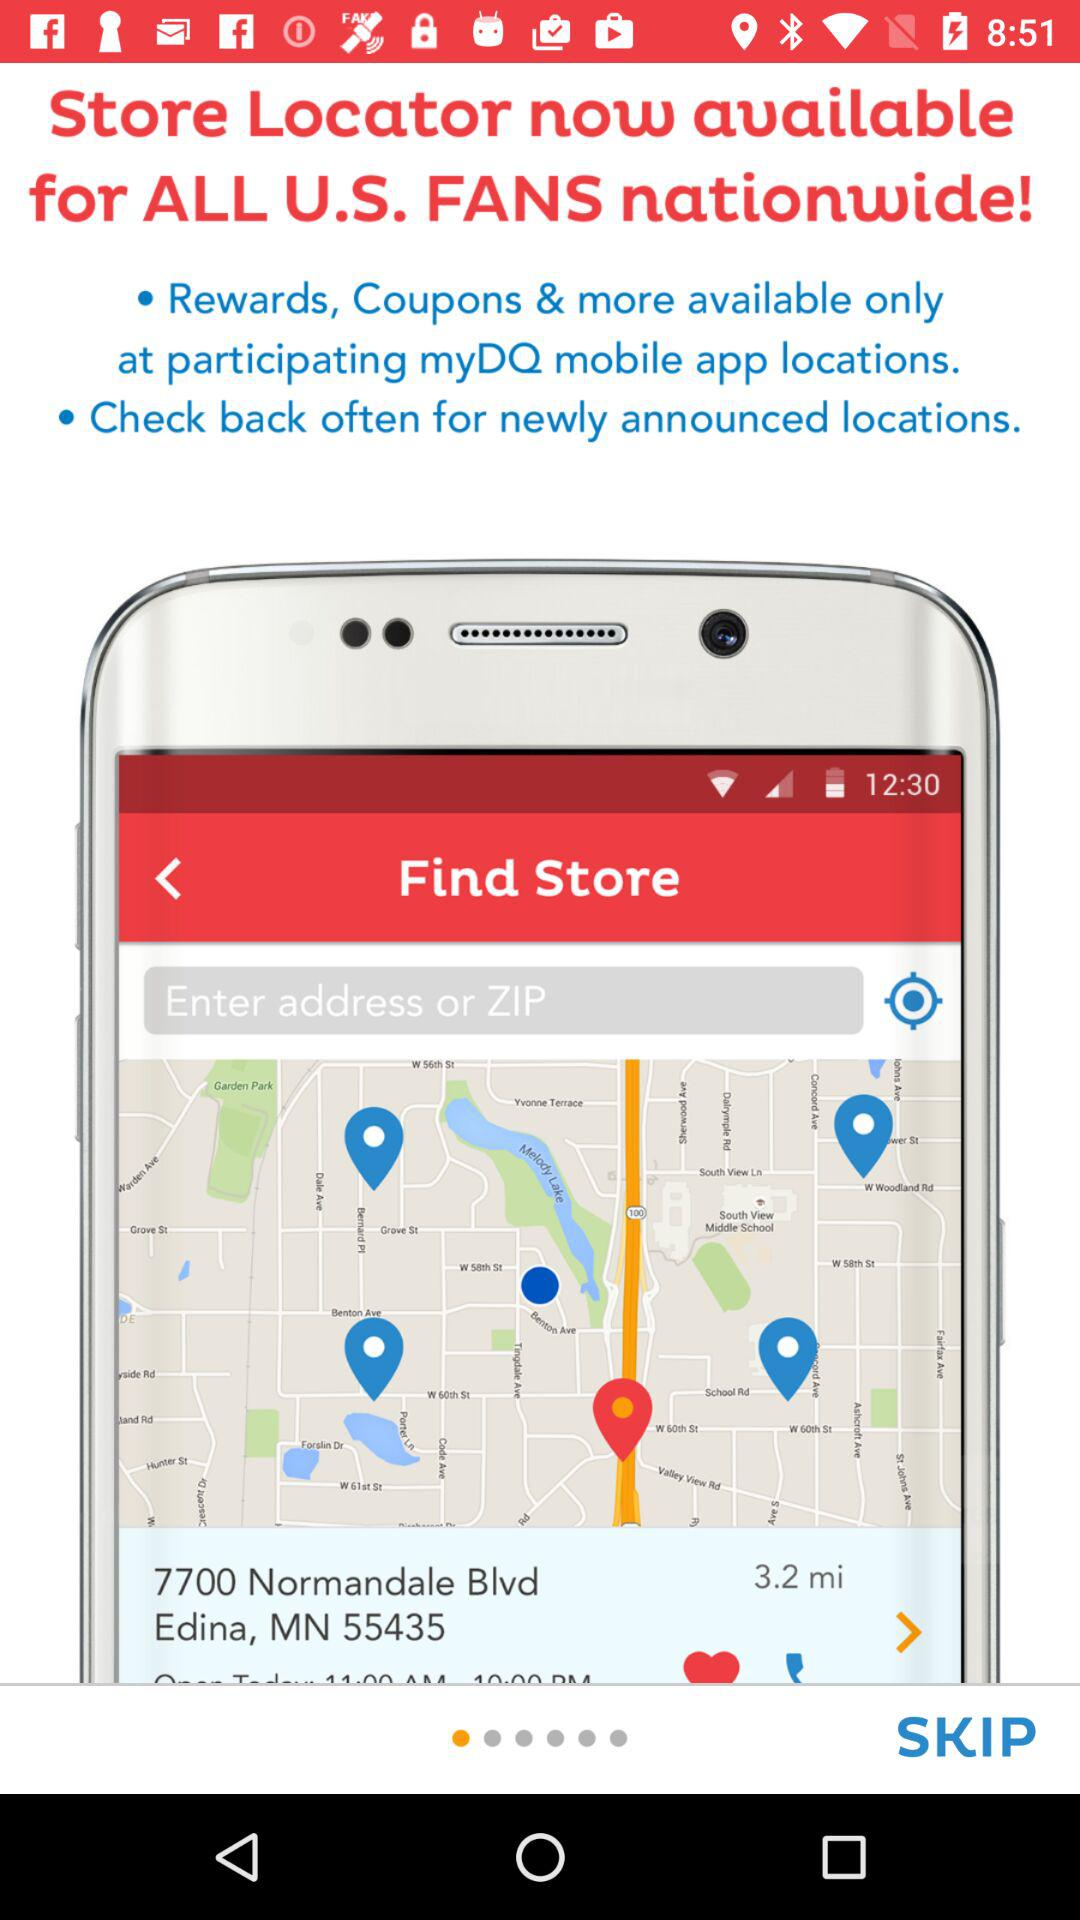What is the name of the application? The name of the application is "Store Locator". 